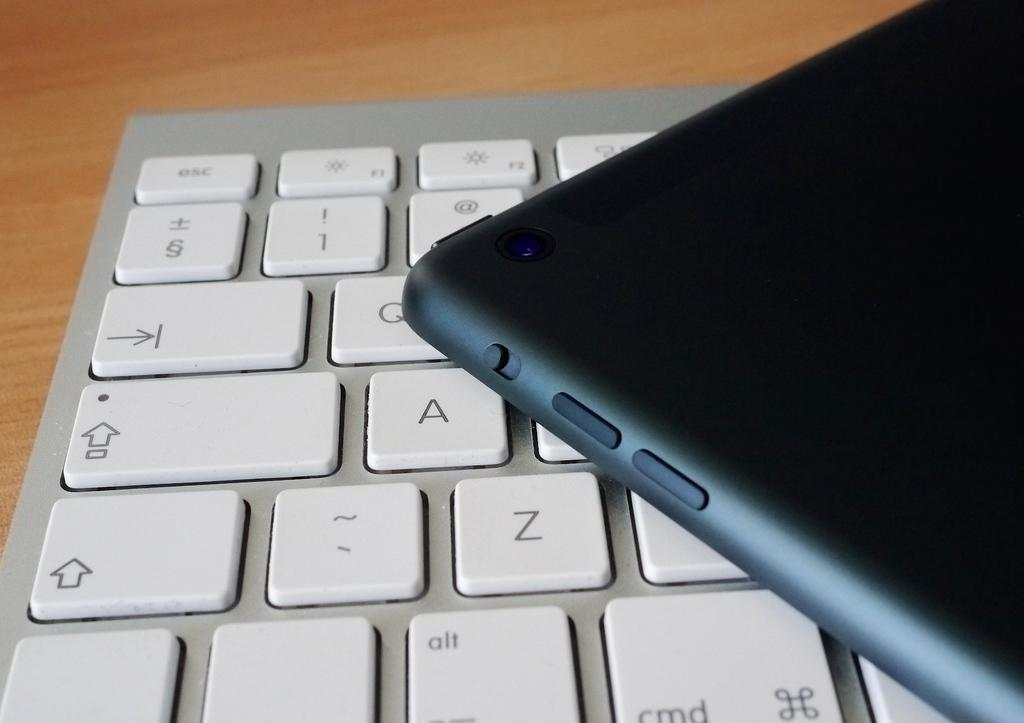<image>
Give a short and clear explanation of the subsequent image. The only number that is visible on the keyboard is 1. 